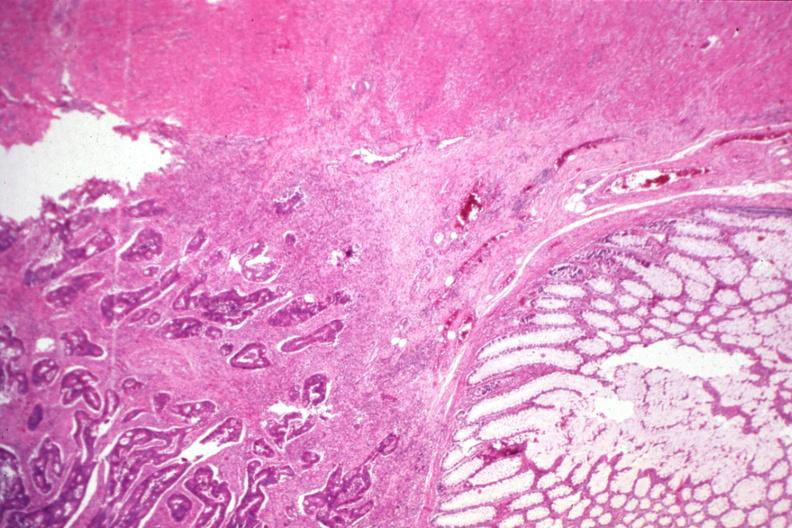where is this from?
Answer the question using a single word or phrase. Gastrointestinal system 